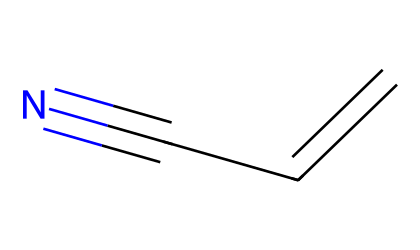What is the name of this chemical? The chemical structure represented by the SMILES C=CC#N corresponds to a compound called acrylonitrile. This is identified by recognizing the "C" atoms and the triple bond indicated by "#", which is characteristic of nitriles.
Answer: acrylonitrile How many carbon atoms are in acrylonitrile? The SMILES representation C=CC#N shows there are three "C" atoms present in the structure. Each "C" stands for a carbon atom, so counting them gives one, two, and three.
Answer: three What is the functional group present in acrylonitrile? The presence of the "#N" in the SMILES indicates that there is a nitrile functional group in acrylonitrile. Nitriles have a carbon atom triple-bonded to a nitrogen atom (#N), which is a defining feature of this compound.
Answer: nitrile How many double or triple bonds are in acrylonitrile? In the SMILES C=CC#N, there is one double bond (C=C) and one triple bond (C#N). The "C=C" shows a double bond between the first and second carbon, and the "#N" indicates a triple bond between the last carbon and the nitrogen. Counting these gives a total of two multiple bonds.
Answer: two Is acrylonitrile a saturated or unsaturated compound? The presence of a double bond (C=C) and a triple bond (C#N) in acrylonitrile indicates it is an unsaturated compound. Saturated compounds have only single bonds, while unsaturated compounds have one or more double or triple bonds. Therefore, acrylonitrile is unsaturated.
Answer: unsaturated What type of chemical reaction could acrylonitrile undergo due to the nitrile group? The nitrile group (C#N) in acrylonitrile can undergo hydrolysis, which is a reaction with water to form an amide or carboxylic acid depending on the reaction conditions. Nitriles generally are reactive towards nucleophiles, making hydrolysis a common reaction.
Answer: hydrolysis 